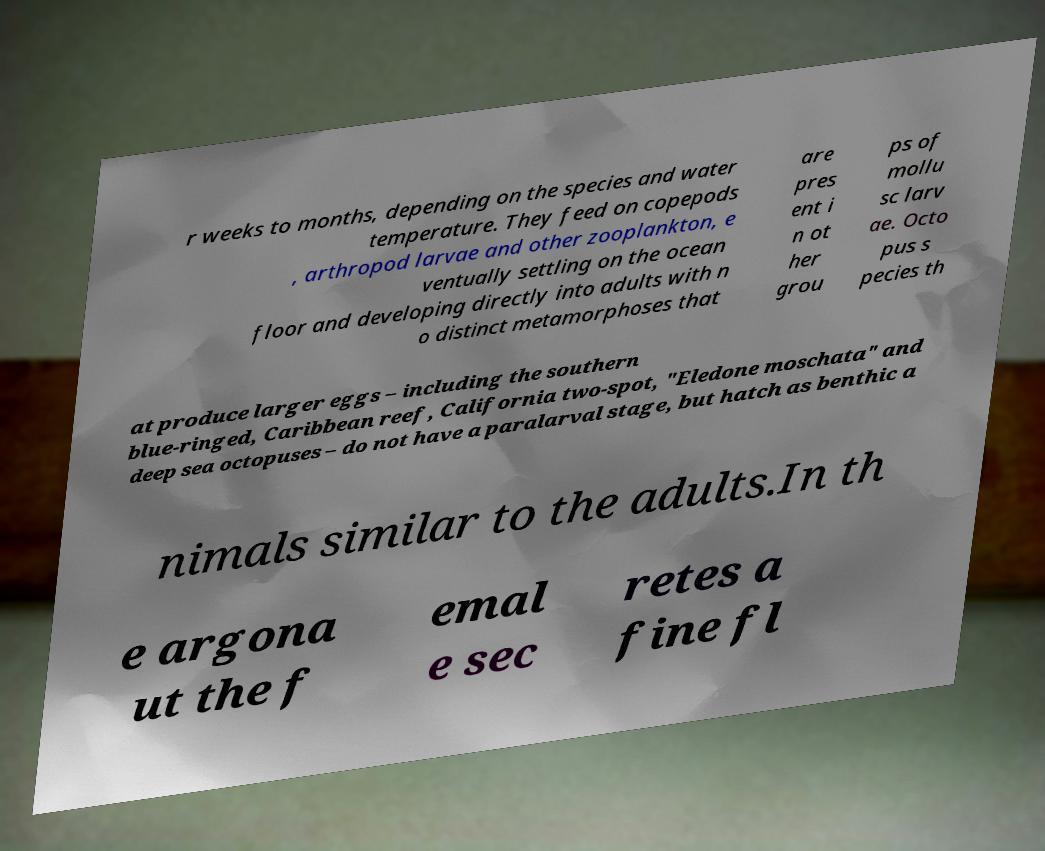Can you accurately transcribe the text from the provided image for me? r weeks to months, depending on the species and water temperature. They feed on copepods , arthropod larvae and other zooplankton, e ventually settling on the ocean floor and developing directly into adults with n o distinct metamorphoses that are pres ent i n ot her grou ps of mollu sc larv ae. Octo pus s pecies th at produce larger eggs – including the southern blue-ringed, Caribbean reef, California two-spot, "Eledone moschata" and deep sea octopuses – do not have a paralarval stage, but hatch as benthic a nimals similar to the adults.In th e argona ut the f emal e sec retes a fine fl 